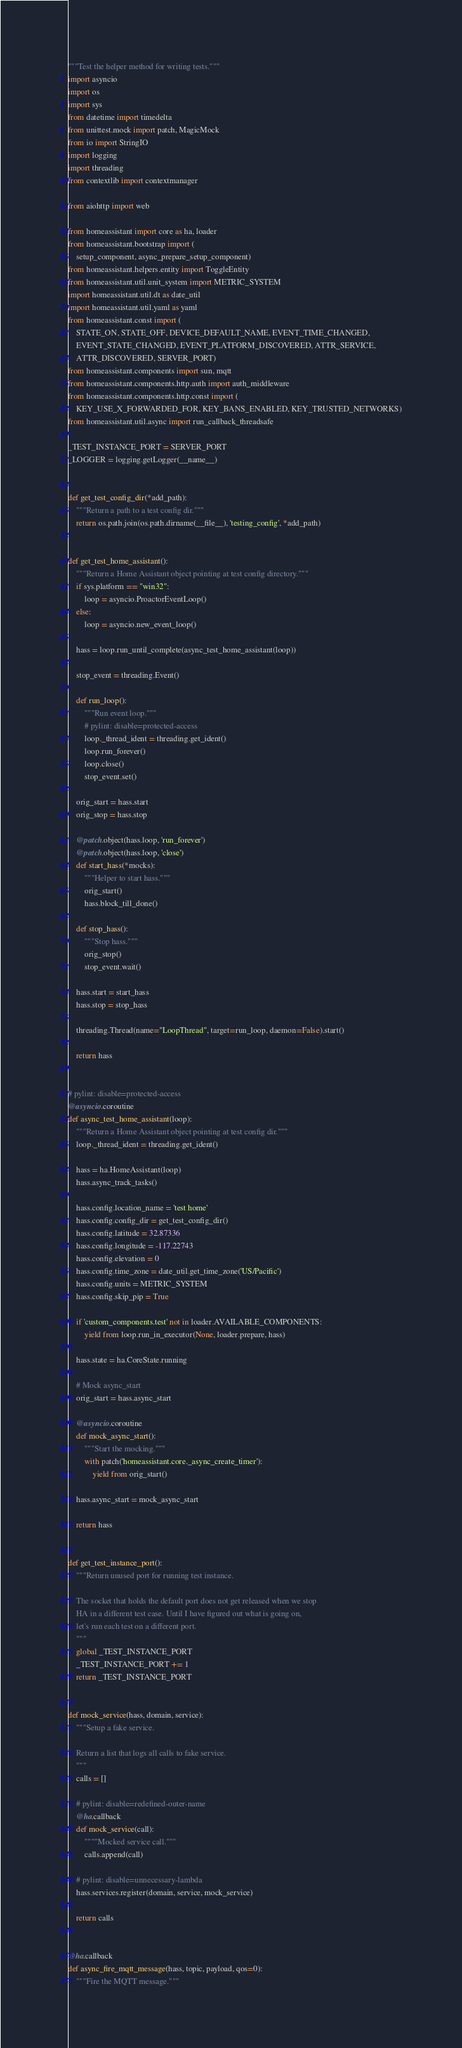<code> <loc_0><loc_0><loc_500><loc_500><_Python_>"""Test the helper method for writing tests."""
import asyncio
import os
import sys
from datetime import timedelta
from unittest.mock import patch, MagicMock
from io import StringIO
import logging
import threading
from contextlib import contextmanager

from aiohttp import web

from homeassistant import core as ha, loader
from homeassistant.bootstrap import (
    setup_component, async_prepare_setup_component)
from homeassistant.helpers.entity import ToggleEntity
from homeassistant.util.unit_system import METRIC_SYSTEM
import homeassistant.util.dt as date_util
import homeassistant.util.yaml as yaml
from homeassistant.const import (
    STATE_ON, STATE_OFF, DEVICE_DEFAULT_NAME, EVENT_TIME_CHANGED,
    EVENT_STATE_CHANGED, EVENT_PLATFORM_DISCOVERED, ATTR_SERVICE,
    ATTR_DISCOVERED, SERVER_PORT)
from homeassistant.components import sun, mqtt
from homeassistant.components.http.auth import auth_middleware
from homeassistant.components.http.const import (
    KEY_USE_X_FORWARDED_FOR, KEY_BANS_ENABLED, KEY_TRUSTED_NETWORKS)
from homeassistant.util.async import run_callback_threadsafe

_TEST_INSTANCE_PORT = SERVER_PORT
_LOGGER = logging.getLogger(__name__)


def get_test_config_dir(*add_path):
    """Return a path to a test config dir."""
    return os.path.join(os.path.dirname(__file__), 'testing_config', *add_path)


def get_test_home_assistant():
    """Return a Home Assistant object pointing at test config directory."""
    if sys.platform == "win32":
        loop = asyncio.ProactorEventLoop()
    else:
        loop = asyncio.new_event_loop()

    hass = loop.run_until_complete(async_test_home_assistant(loop))

    stop_event = threading.Event()

    def run_loop():
        """Run event loop."""
        # pylint: disable=protected-access
        loop._thread_ident = threading.get_ident()
        loop.run_forever()
        loop.close()
        stop_event.set()

    orig_start = hass.start
    orig_stop = hass.stop

    @patch.object(hass.loop, 'run_forever')
    @patch.object(hass.loop, 'close')
    def start_hass(*mocks):
        """Helper to start hass."""
        orig_start()
        hass.block_till_done()

    def stop_hass():
        """Stop hass."""
        orig_stop()
        stop_event.wait()

    hass.start = start_hass
    hass.stop = stop_hass

    threading.Thread(name="LoopThread", target=run_loop, daemon=False).start()

    return hass


# pylint: disable=protected-access
@asyncio.coroutine
def async_test_home_assistant(loop):
    """Return a Home Assistant object pointing at test config dir."""
    loop._thread_ident = threading.get_ident()

    hass = ha.HomeAssistant(loop)
    hass.async_track_tasks()

    hass.config.location_name = 'test home'
    hass.config.config_dir = get_test_config_dir()
    hass.config.latitude = 32.87336
    hass.config.longitude = -117.22743
    hass.config.elevation = 0
    hass.config.time_zone = date_util.get_time_zone('US/Pacific')
    hass.config.units = METRIC_SYSTEM
    hass.config.skip_pip = True

    if 'custom_components.test' not in loader.AVAILABLE_COMPONENTS:
        yield from loop.run_in_executor(None, loader.prepare, hass)

    hass.state = ha.CoreState.running

    # Mock async_start
    orig_start = hass.async_start

    @asyncio.coroutine
    def mock_async_start():
        """Start the mocking."""
        with patch('homeassistant.core._async_create_timer'):
            yield from orig_start()

    hass.async_start = mock_async_start

    return hass


def get_test_instance_port():
    """Return unused port for running test instance.

    The socket that holds the default port does not get released when we stop
    HA in a different test case. Until I have figured out what is going on,
    let's run each test on a different port.
    """
    global _TEST_INSTANCE_PORT
    _TEST_INSTANCE_PORT += 1
    return _TEST_INSTANCE_PORT


def mock_service(hass, domain, service):
    """Setup a fake service.

    Return a list that logs all calls to fake service.
    """
    calls = []

    # pylint: disable=redefined-outer-name
    @ha.callback
    def mock_service(call):
        """"Mocked service call."""
        calls.append(call)

    # pylint: disable=unnecessary-lambda
    hass.services.register(domain, service, mock_service)

    return calls


@ha.callback
def async_fire_mqtt_message(hass, topic, payload, qos=0):
    """Fire the MQTT message."""</code> 